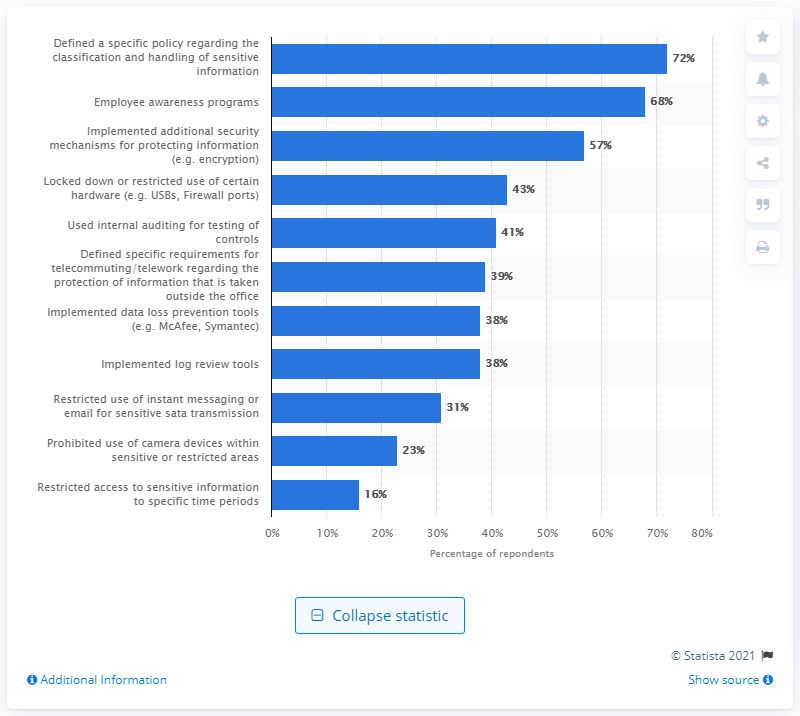Highlight a few significant elements in this photo. According to the results, 72% of respondents have defined a policy for the classification and handling of sensitive data as a control for data leakage risk. 